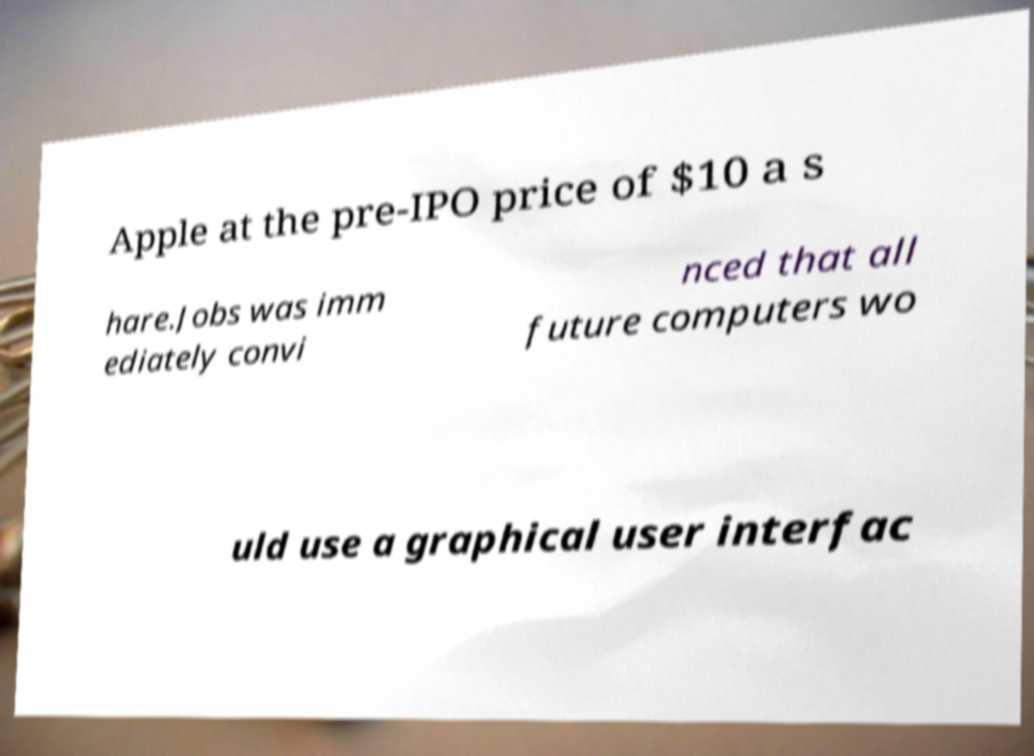Please read and relay the text visible in this image. What does it say? Apple at the pre-IPO price of $10 a s hare.Jobs was imm ediately convi nced that all future computers wo uld use a graphical user interfac 